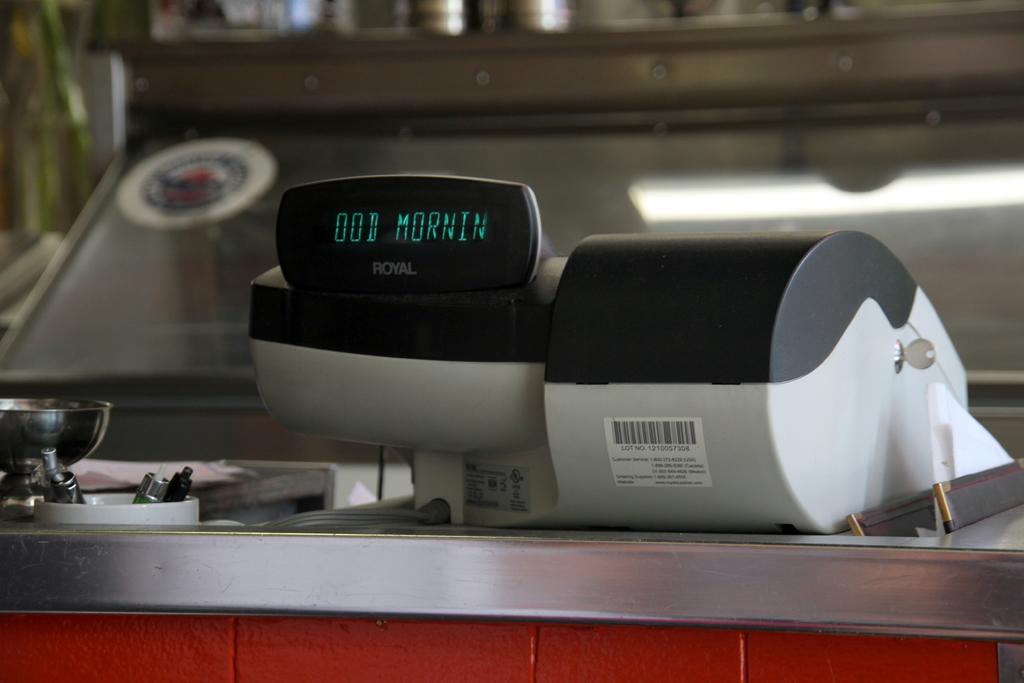What does it say?
Provide a succinct answer. Ood mornin. 